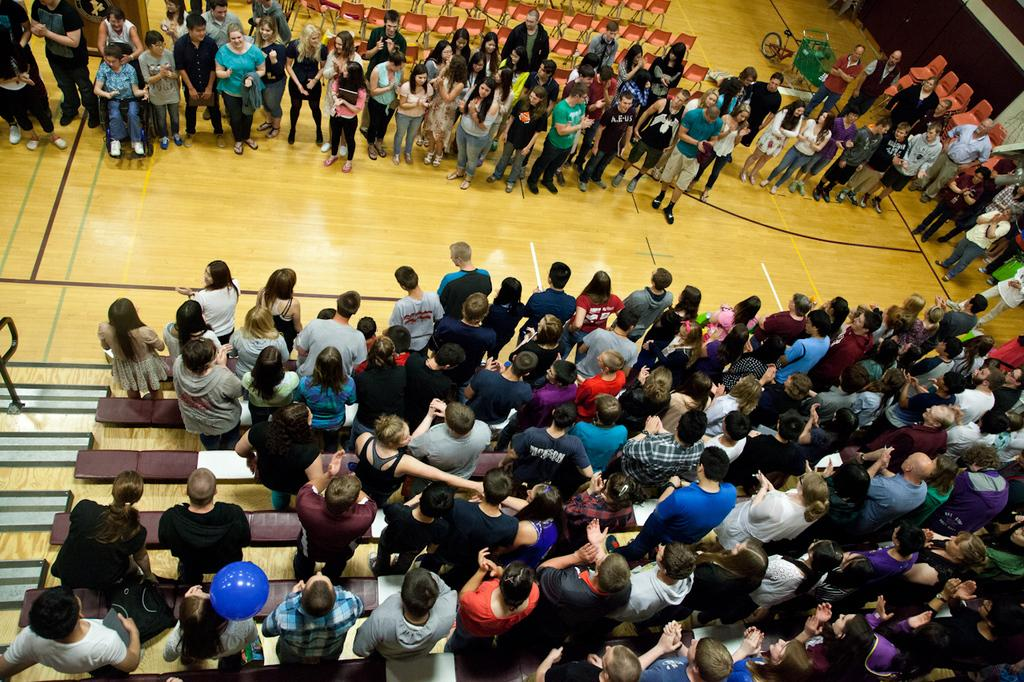What are the people in the image doing? There is a group of people on the floor in the image. What furniture is present in the image? There are chairs and seats in the image. What can be seen at the top of the image? There is a vehicle visible at the top of the image. What type of amusement can be seen in the image? There is no amusement present in the image; it features a group of people on the floor, chairs and seats, and a vehicle at the top. How many ears can be seen on the zebra in the image? There is no zebra present in the image. 